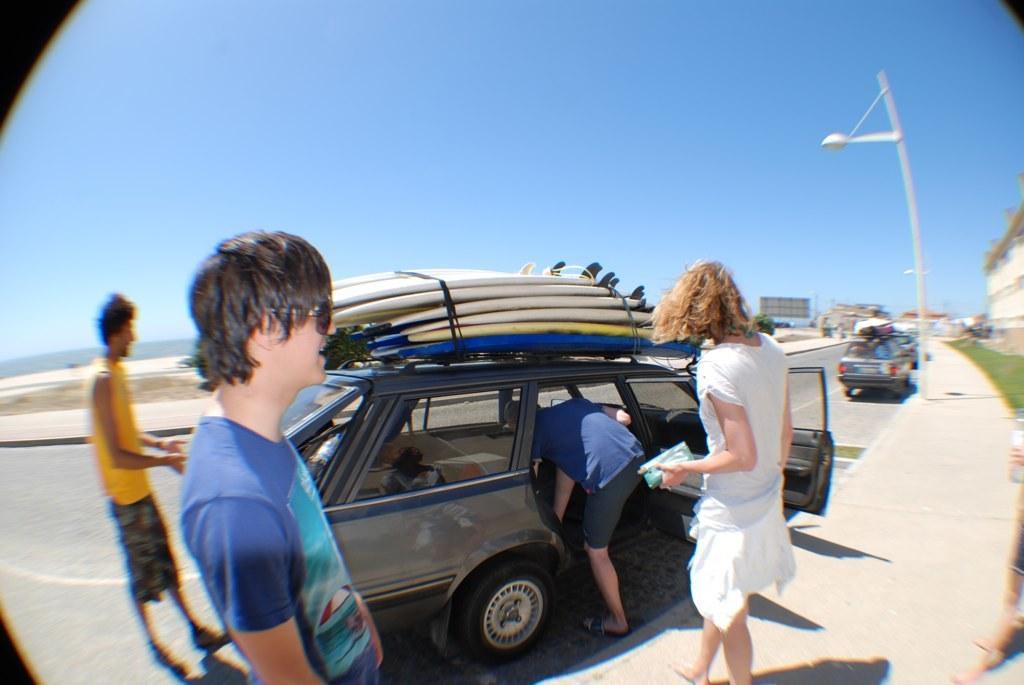Could you give a brief overview of what you see in this image? This picture is reflection of a glass. In the image there are cars parked on the road. The car that is in center, there things placed on the barrier. There are few people around the car. There is a street light in the image. In the background there is a building, grass, walkway, hoarding and sky. 